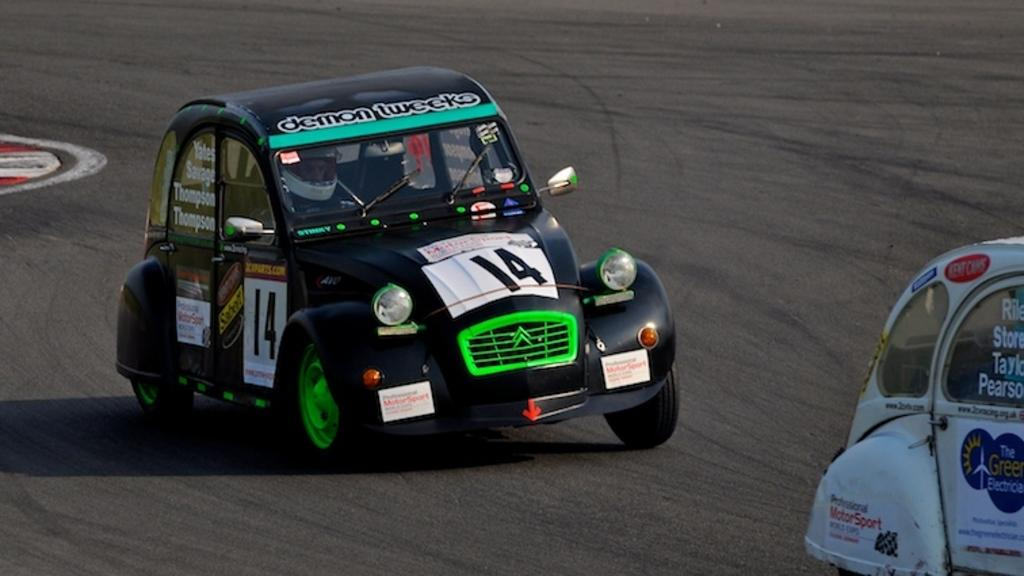What type of vehicles can be seen in the image? There are cars in the image. What is written on the cars? There is text written on the cars. What is the primary setting in the image? There is a road visible in the image. How many bags are being carried by the brothers in the image? There are no bags or brothers present in the image. 